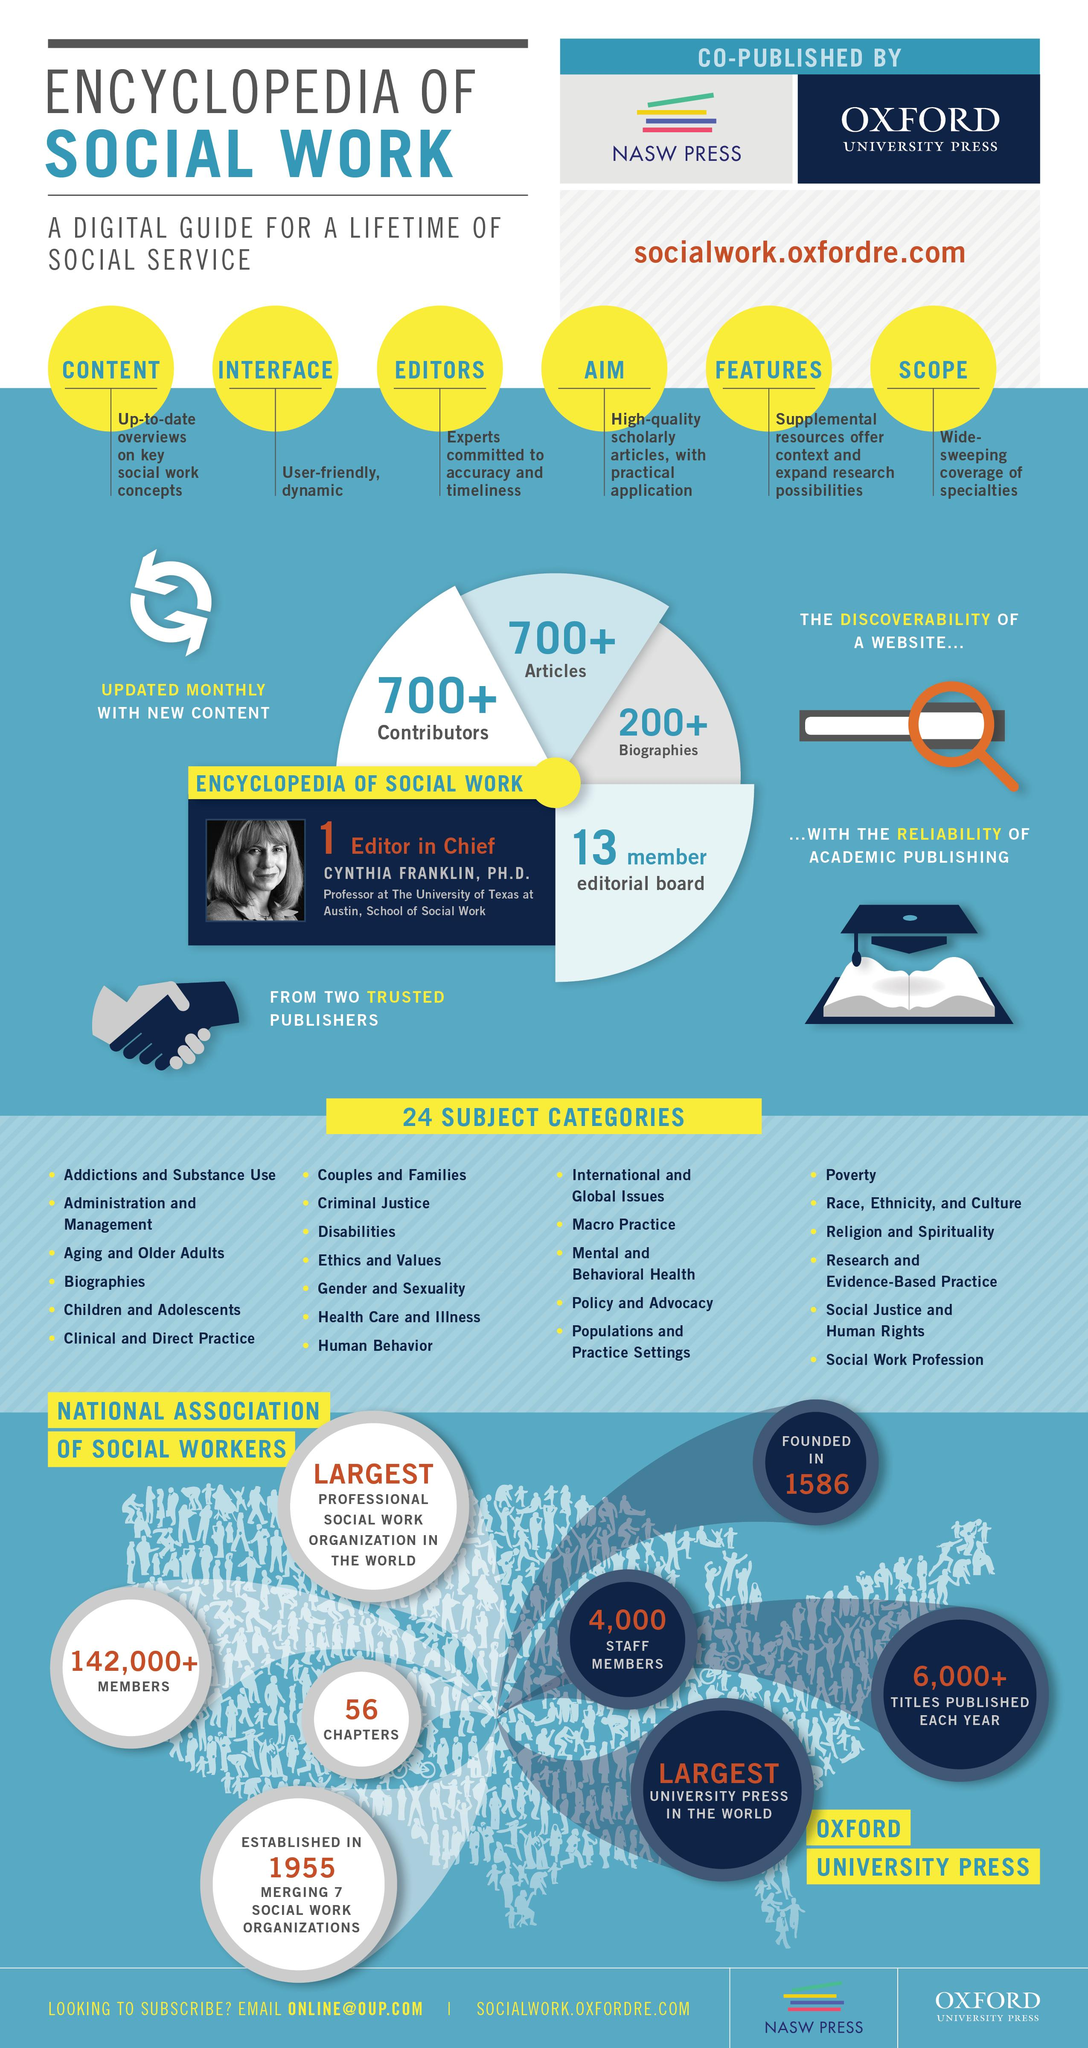Highlight a few significant elements in this photo. Oxford University Press was established in 1586. The Encyclopedia of Social Work contains over 700 contributors and articles. The National Association of Social Workers has over 142,000 members, with over 4,000 additional members. Oxford University Press has approximately 4,000 staff members. 